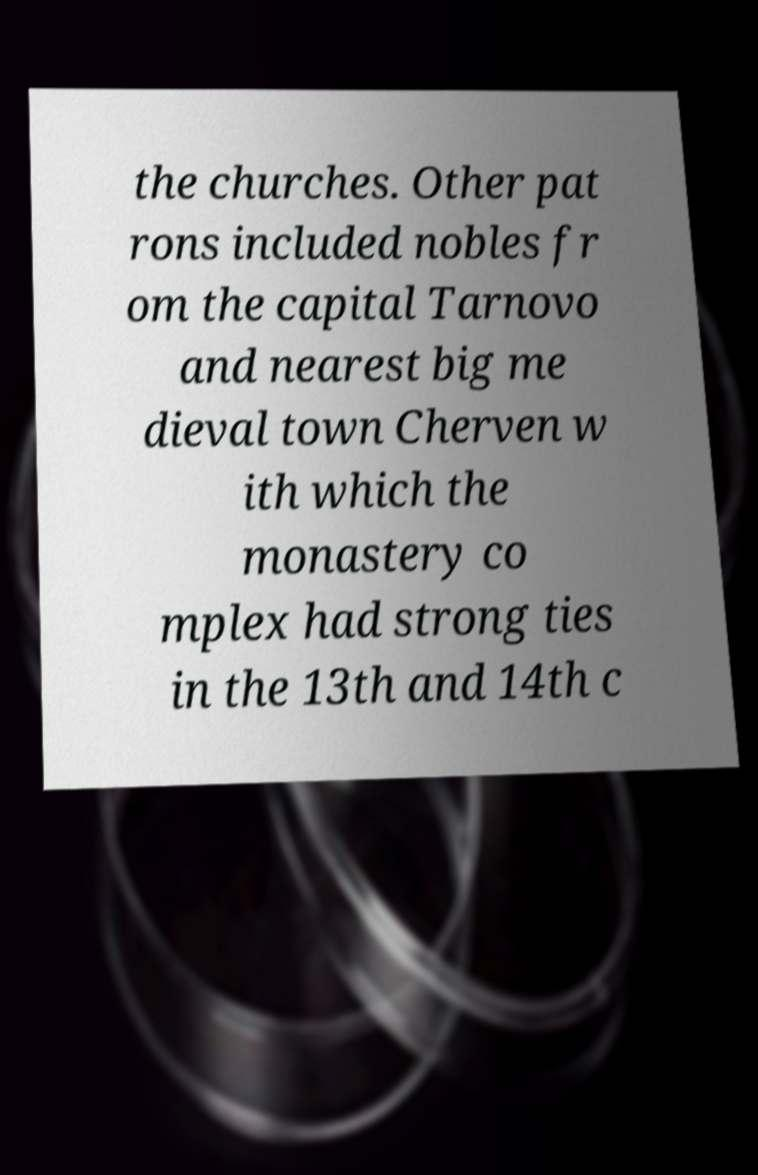For documentation purposes, I need the text within this image transcribed. Could you provide that? the churches. Other pat rons included nobles fr om the capital Tarnovo and nearest big me dieval town Cherven w ith which the monastery co mplex had strong ties in the 13th and 14th c 